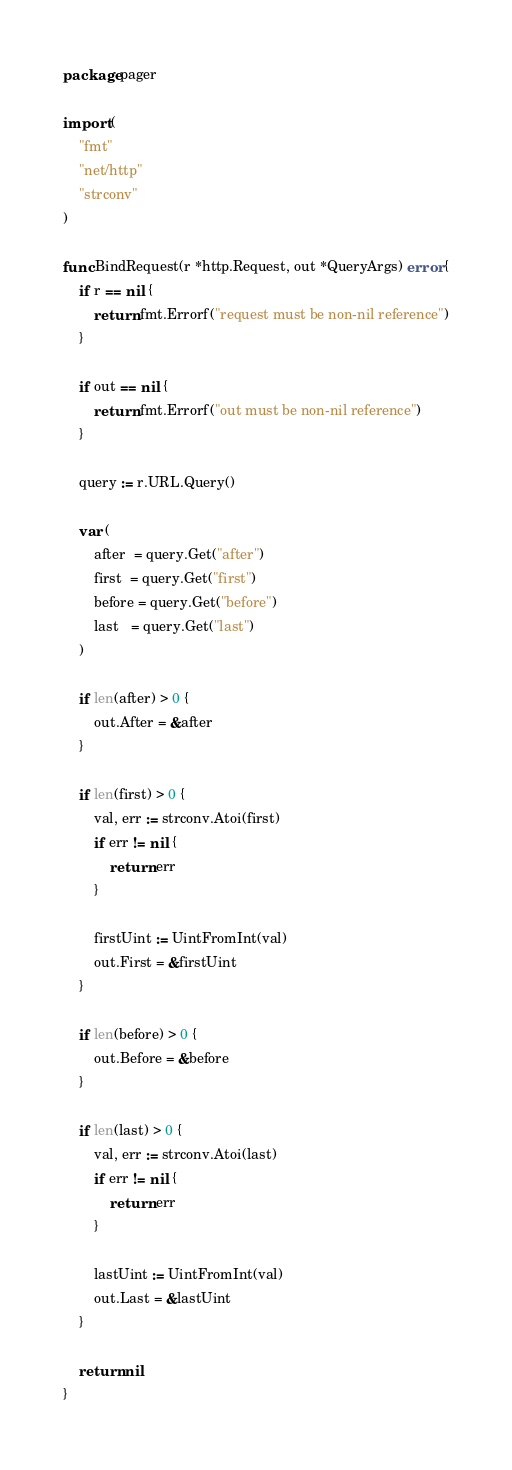Convert code to text. <code><loc_0><loc_0><loc_500><loc_500><_Go_>package pager

import (
	"fmt"
	"net/http"
	"strconv"
)

func BindRequest(r *http.Request, out *QueryArgs) error {
	if r == nil {
		return fmt.Errorf("request must be non-nil reference")
	}

	if out == nil {
		return fmt.Errorf("out must be non-nil reference")
	}

	query := r.URL.Query()

	var (
		after  = query.Get("after")
		first  = query.Get("first")
		before = query.Get("before")
		last   = query.Get("last")
	)

	if len(after) > 0 {
		out.After = &after
	}

	if len(first) > 0 {
		val, err := strconv.Atoi(first)
		if err != nil {
			return err
		}

		firstUint := UintFromInt(val)
		out.First = &firstUint
	}

	if len(before) > 0 {
		out.Before = &before
	}

	if len(last) > 0 {
		val, err := strconv.Atoi(last)
		if err != nil {
			return err
		}

		lastUint := UintFromInt(val)
		out.Last = &lastUint
	}

	return nil
}
</code> 